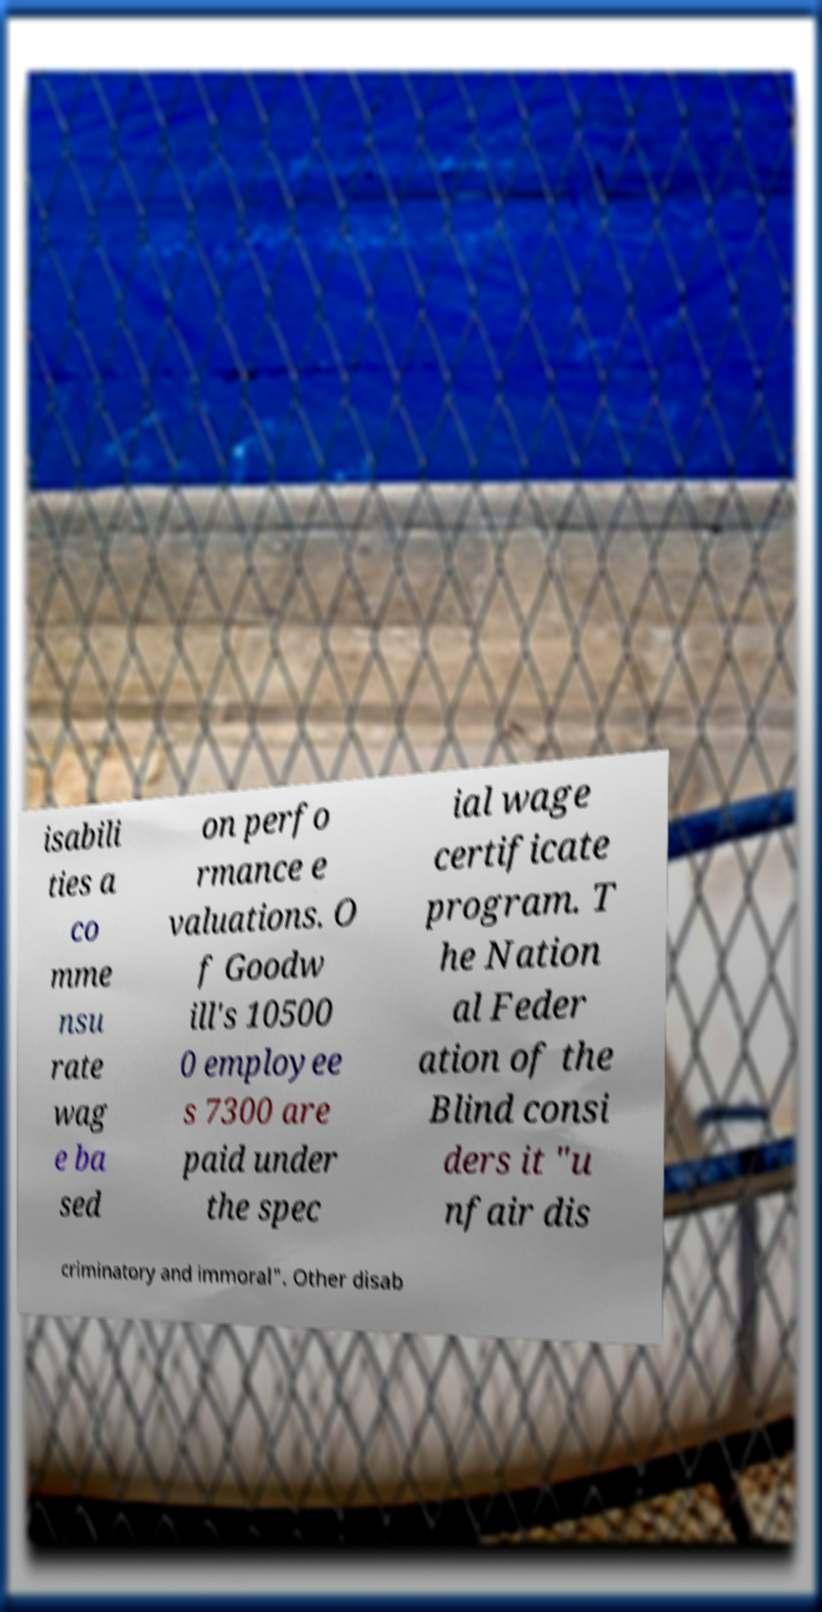Please identify and transcribe the text found in this image. isabili ties a co mme nsu rate wag e ba sed on perfo rmance e valuations. O f Goodw ill's 10500 0 employee s 7300 are paid under the spec ial wage certificate program. T he Nation al Feder ation of the Blind consi ders it "u nfair dis criminatory and immoral". Other disab 